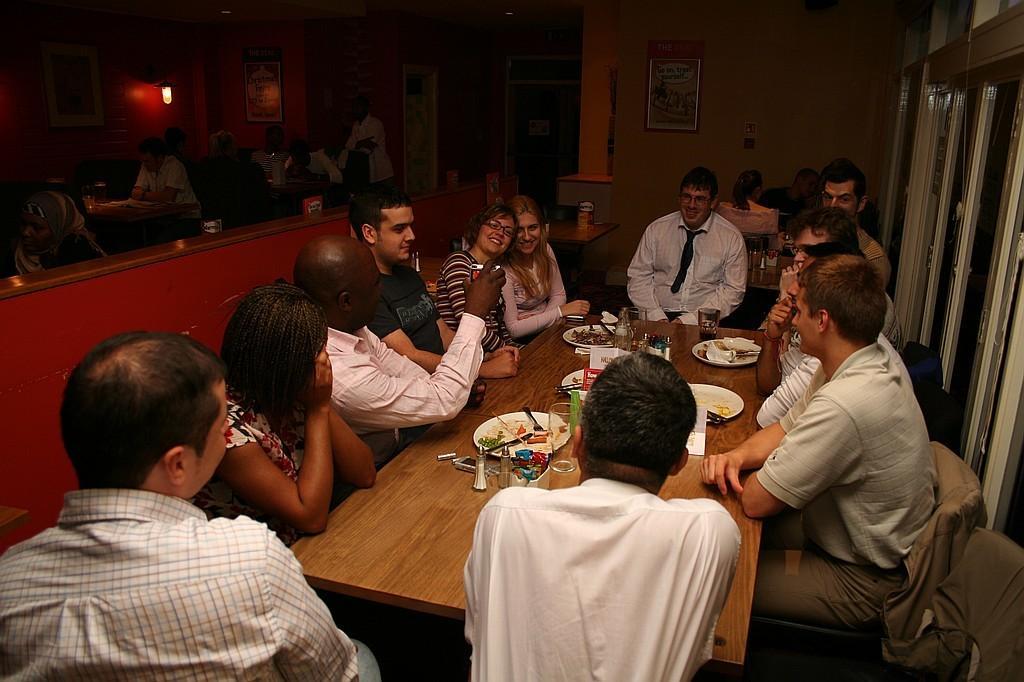Describe this image in one or two sentences. This image is taken inside the restaurant. In the left side of the image there is a sofa and a man sitting on it. There are many people in this image. In the middle of the image there is a table which has plate, fork, knife, salt and pepper, glass with water and tissues and a man placing his hands on this table and sitting on a chair. In the left side of the image there is a man sitting in a chair and placing his hands on table and a window. At the top of the image there is wall and a frame on it and a lamp at the left top most of the image. 